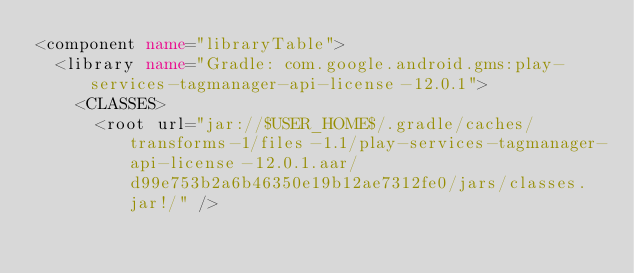<code> <loc_0><loc_0><loc_500><loc_500><_XML_><component name="libraryTable">
  <library name="Gradle: com.google.android.gms:play-services-tagmanager-api-license-12.0.1">
    <CLASSES>
      <root url="jar://$USER_HOME$/.gradle/caches/transforms-1/files-1.1/play-services-tagmanager-api-license-12.0.1.aar/d99e753b2a6b46350e19b12ae7312fe0/jars/classes.jar!/" /></code> 